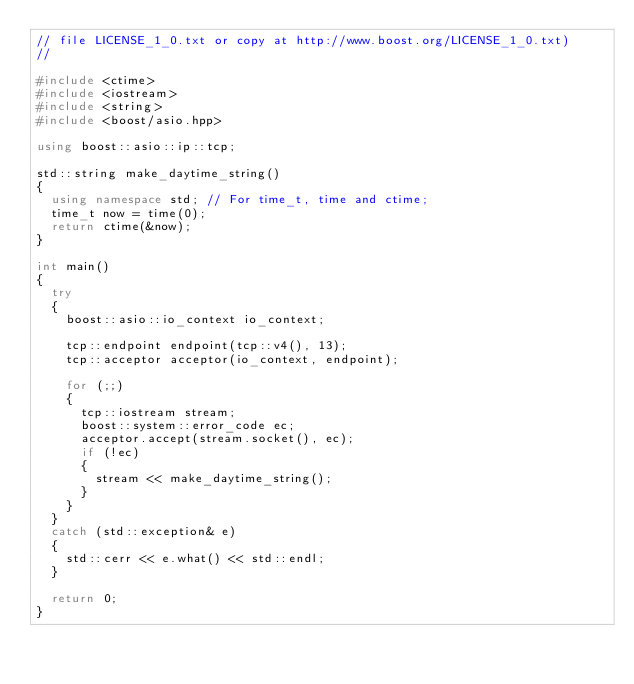Convert code to text. <code><loc_0><loc_0><loc_500><loc_500><_C++_>// file LICENSE_1_0.txt or copy at http://www.boost.org/LICENSE_1_0.txt)
//

#include <ctime>
#include <iostream>
#include <string>
#include <boost/asio.hpp>

using boost::asio::ip::tcp;

std::string make_daytime_string()
{
  using namespace std; // For time_t, time and ctime;
  time_t now = time(0);
  return ctime(&now);
}

int main()
{
  try
  {
    boost::asio::io_context io_context;

    tcp::endpoint endpoint(tcp::v4(), 13);
    tcp::acceptor acceptor(io_context, endpoint);

    for (;;)
    {
      tcp::iostream stream;
      boost::system::error_code ec;
      acceptor.accept(stream.socket(), ec);
      if (!ec)
      {
        stream << make_daytime_string();
      }
    }
  }
  catch (std::exception& e)
  {
    std::cerr << e.what() << std::endl;
  }

  return 0;
}
</code> 